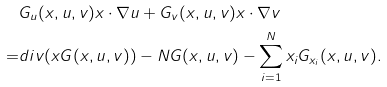Convert formula to latex. <formula><loc_0><loc_0><loc_500><loc_500>& G _ { u } ( x , u , v ) x \cdot \nabla u + G _ { v } ( x , u , v ) x \cdot \nabla v \\ = & d i v ( x G ( x , u , v ) ) - N G ( x , u , v ) - \sum _ { i = 1 } ^ { N } x _ { i } G _ { x _ { i } } ( x , u , v ) .</formula> 